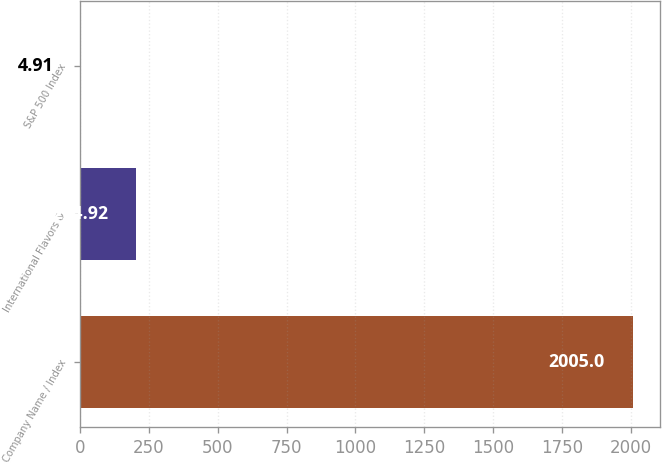<chart> <loc_0><loc_0><loc_500><loc_500><bar_chart><fcel>Company Name / Index<fcel>International Flavors &<fcel>S&P 500 Index<nl><fcel>2005<fcel>204.92<fcel>4.91<nl></chart> 